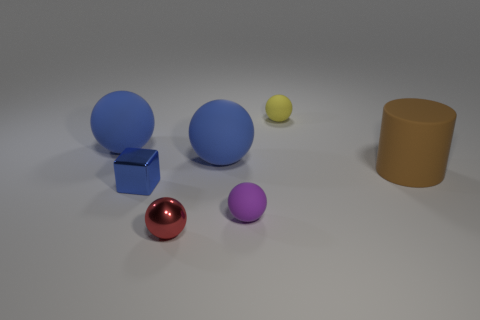Subtract all yellow spheres. How many spheres are left? 4 Subtract all tiny red metal spheres. How many spheres are left? 4 Subtract all green spheres. Subtract all gray cylinders. How many spheres are left? 5 Add 1 large blue objects. How many objects exist? 8 Subtract all blocks. How many objects are left? 6 Add 5 brown matte cylinders. How many brown matte cylinders exist? 6 Subtract 0 green balls. How many objects are left? 7 Subtract all cylinders. Subtract all blue things. How many objects are left? 3 Add 3 brown rubber objects. How many brown rubber objects are left? 4 